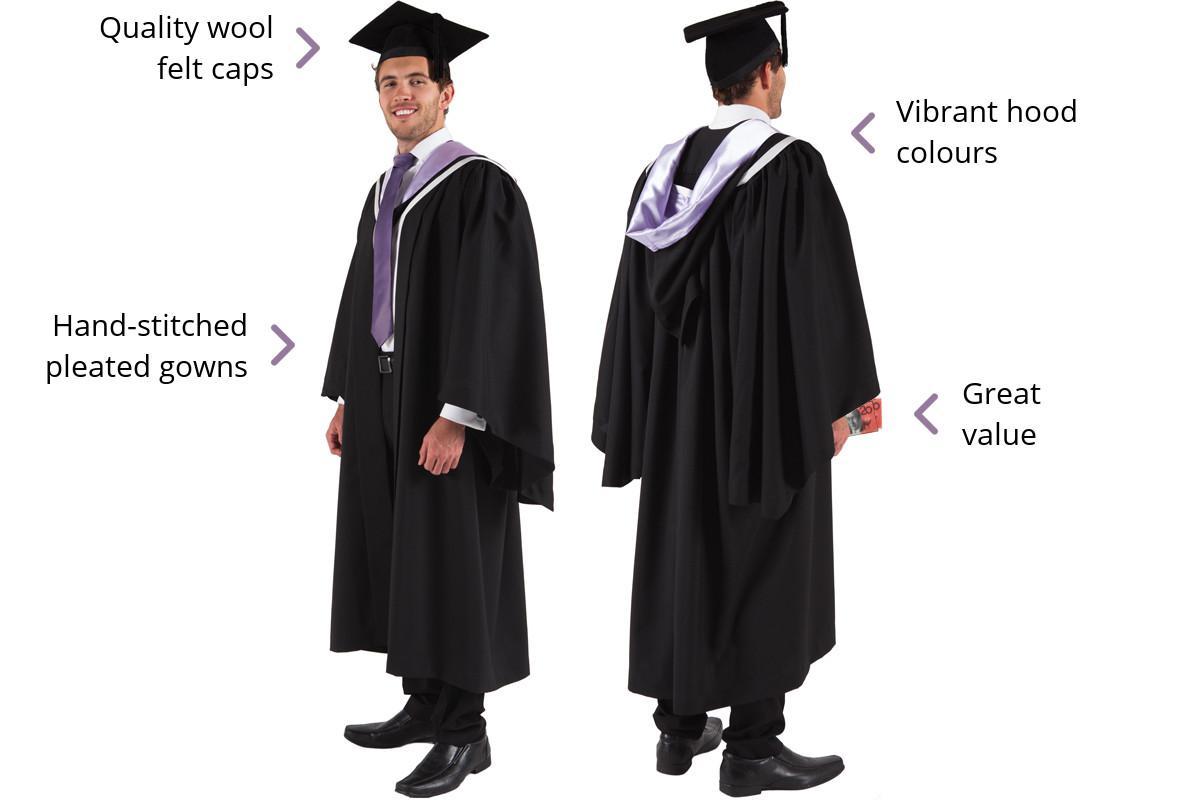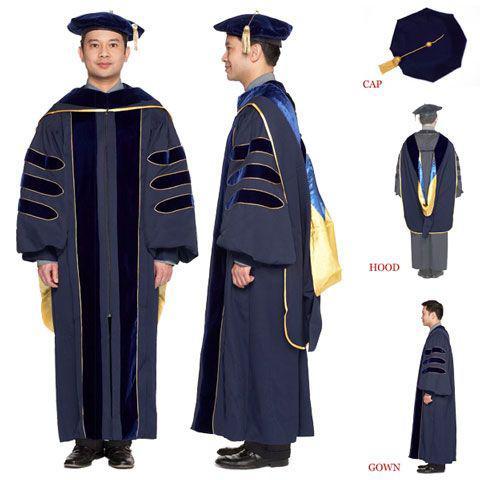The first image is the image on the left, the second image is the image on the right. Examine the images to the left and right. Is the description "The full lengths of all graduation gowns are shown." accurate? Answer yes or no. Yes. 